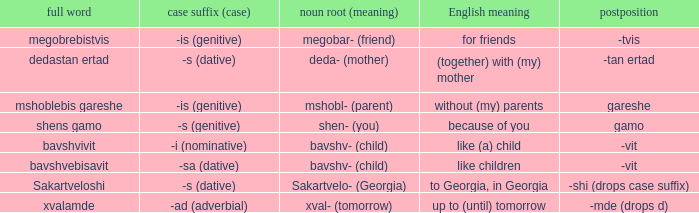What is the Full Word, when Case Suffix (case) is "-sa (dative)"? Bavshvebisavit. 